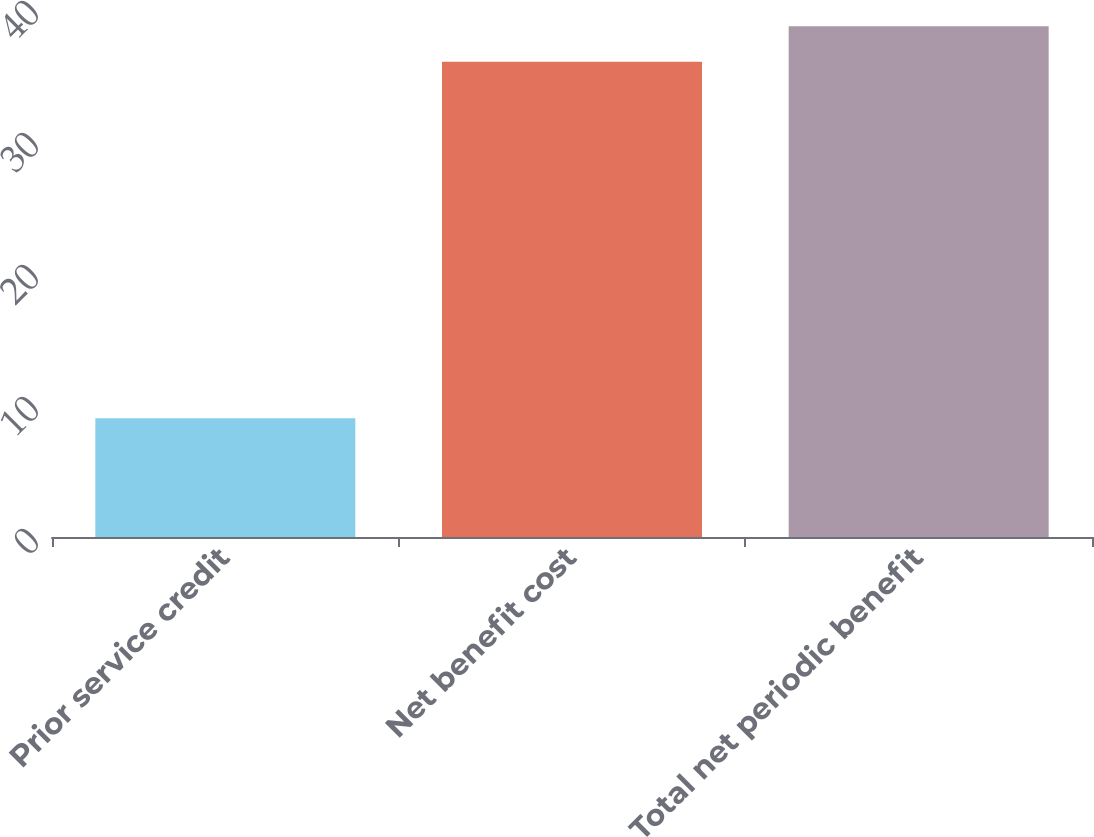<chart> <loc_0><loc_0><loc_500><loc_500><bar_chart><fcel>Prior service credit<fcel>Net benefit cost<fcel>Total net periodic benefit<nl><fcel>9<fcel>36<fcel>38.7<nl></chart> 